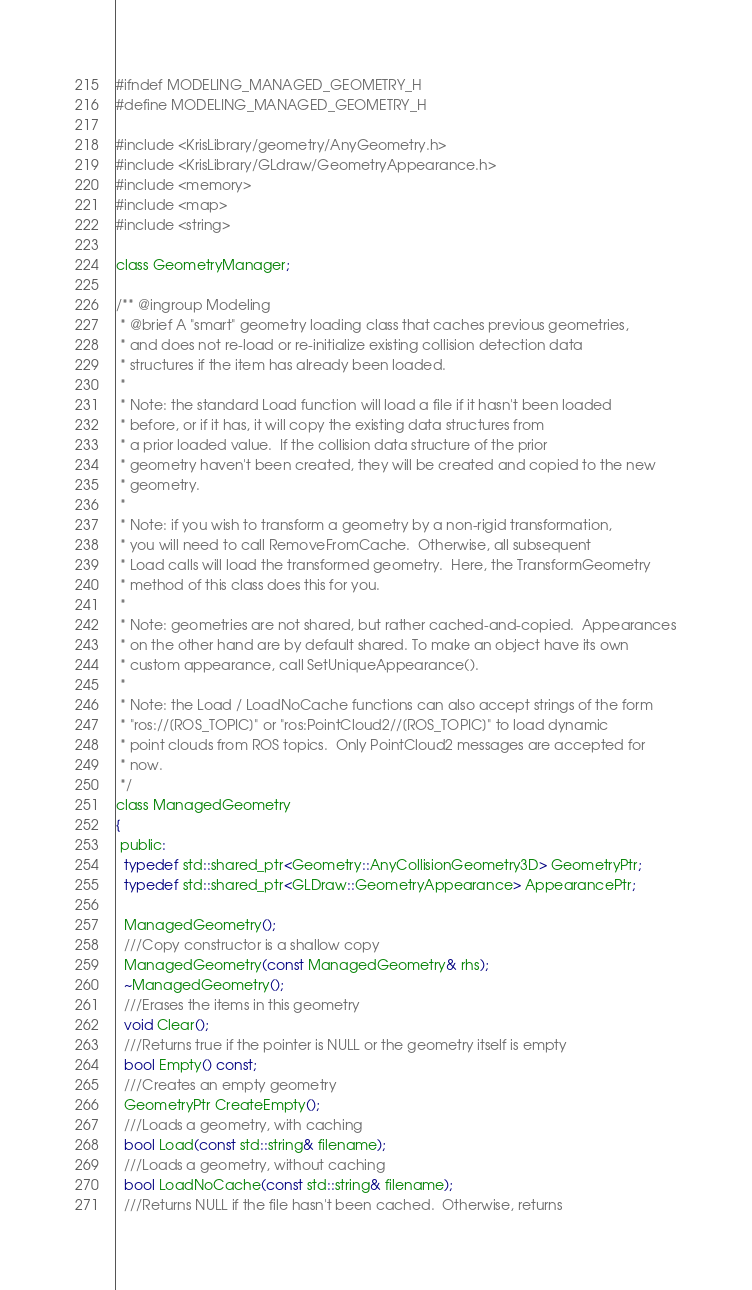<code> <loc_0><loc_0><loc_500><loc_500><_C_>#ifndef MODELING_MANAGED_GEOMETRY_H
#define MODELING_MANAGED_GEOMETRY_H

#include <KrisLibrary/geometry/AnyGeometry.h>
#include <KrisLibrary/GLdraw/GeometryAppearance.h>
#include <memory>
#include <map>
#include <string>

class GeometryManager;

/** @ingroup Modeling
 * @brief A "smart" geometry loading class that caches previous geometries,
 * and does not re-load or re-initialize existing collision detection data
 * structures if the item has already been loaded.
 *
 * Note: the standard Load function will load a file if it hasn't been loaded
 * before, or if it has, it will copy the existing data structures from
 * a prior loaded value.  If the collision data structure of the prior
 * geometry haven't been created, they will be created and copied to the new
 * geometry.
 *
 * Note: if you wish to transform a geometry by a non-rigid transformation, 
 * you will need to call RemoveFromCache.  Otherwise, all subsequent
 * Load calls will load the transformed geometry.  Here, the TransformGeometry
 * method of this class does this for you.
 *
 * Note: geometries are not shared, but rather cached-and-copied.  Appearances
 * on the other hand are by default shared. To make an object have its own
 * custom appearance, call SetUniqueAppearance().
 *
 * Note: the Load / LoadNoCache functions can also accept strings of the form
 * "ros://[ROS_TOPIC]" or "ros:PointCloud2//[ROS_TOPIC]" to load dynamic 
 * point clouds from ROS topics.  Only PointCloud2 messages are accepted for
 * now.
 */
class ManagedGeometry
{
 public:
  typedef std::shared_ptr<Geometry::AnyCollisionGeometry3D> GeometryPtr;
  typedef std::shared_ptr<GLDraw::GeometryAppearance> AppearancePtr;

  ManagedGeometry();
  ///Copy constructor is a shallow copy
  ManagedGeometry(const ManagedGeometry& rhs);
  ~ManagedGeometry();
  ///Erases the items in this geometry
  void Clear();
  ///Returns true if the pointer is NULL or the geometry itself is empty
  bool Empty() const;
  ///Creates an empty geometry
  GeometryPtr CreateEmpty();
  ///Loads a geometry, with caching
  bool Load(const std::string& filename);
  ///Loads a geometry, without caching
  bool LoadNoCache(const std::string& filename);
  ///Returns NULL if the file hasn't been cached.  Otherwise, returns</code> 